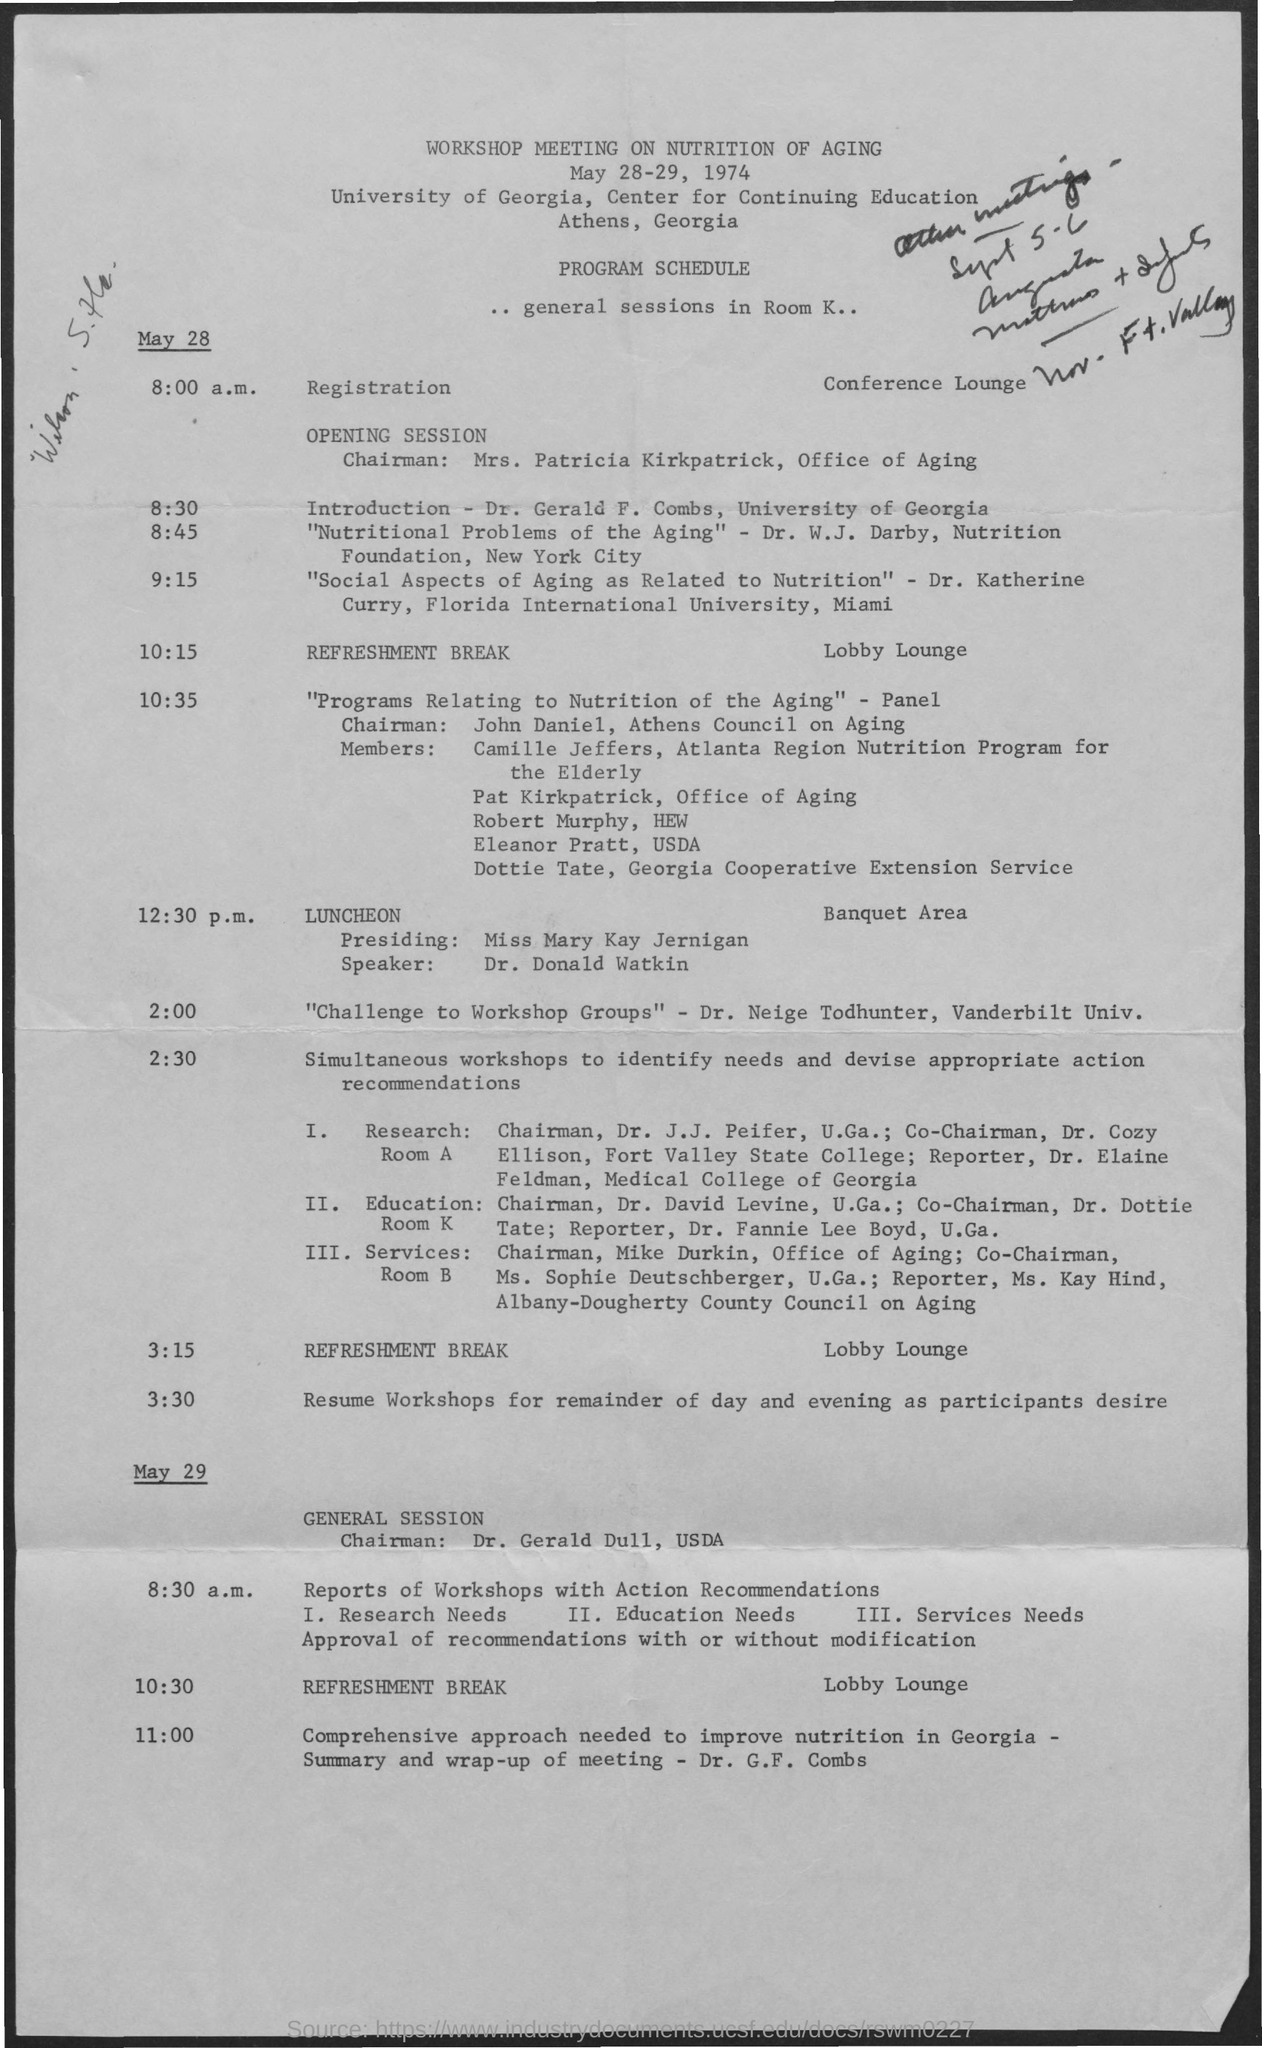What is the workshop meeting about ?
Provide a short and direct response. Nutrition of Aging. Who is giving the introduction speech?
Provide a succinct answer. Dr. Gerald F. Combs, University of Georgia. From which university is Dr. Katherine Curry ?
Keep it short and to the point. Florida International University. Who is the chairman of the general session on may 29?
Your answer should be compact. Dr. Gerald Dull, USDA. 